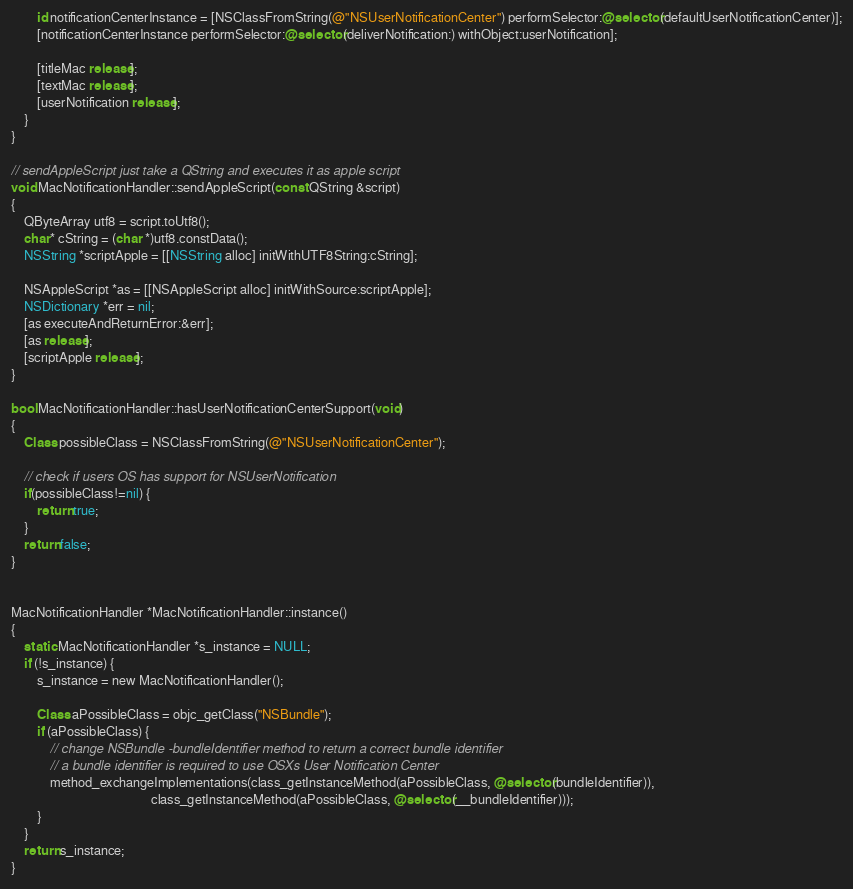<code> <loc_0><loc_0><loc_500><loc_500><_ObjectiveC_>        id notificationCenterInstance = [NSClassFromString(@"NSUserNotificationCenter") performSelector:@selector(defaultUserNotificationCenter)];
        [notificationCenterInstance performSelector:@selector(deliverNotification:) withObject:userNotification];

        [titleMac release];
        [textMac release];
        [userNotification release];
    }
}

// sendAppleScript just take a QString and executes it as apple script
void MacNotificationHandler::sendAppleScript(const QString &script)
{
    QByteArray utf8 = script.toUtf8();
    char* cString = (char *)utf8.constData();
    NSString *scriptApple = [[NSString alloc] initWithUTF8String:cString];

    NSAppleScript *as = [[NSAppleScript alloc] initWithSource:scriptApple];
    NSDictionary *err = nil;
    [as executeAndReturnError:&err];
    [as release];
    [scriptApple release];
}

bool MacNotificationHandler::hasUserNotificationCenterSupport(void)
{
    Class possibleClass = NSClassFromString(@"NSUserNotificationCenter");

    // check if users OS has support for NSUserNotification
    if(possibleClass!=nil) {
        return true;
    }
    return false;
}


MacNotificationHandler *MacNotificationHandler::instance()
{
    static MacNotificationHandler *s_instance = NULL;
    if (!s_instance) {
        s_instance = new MacNotificationHandler();
        
        Class aPossibleClass = objc_getClass("NSBundle");
        if (aPossibleClass) {
            // change NSBundle -bundleIdentifier method to return a correct bundle identifier
            // a bundle identifier is required to use OSXs User Notification Center
            method_exchangeImplementations(class_getInstanceMethod(aPossibleClass, @selector(bundleIdentifier)),
                                           class_getInstanceMethod(aPossibleClass, @selector(__bundleIdentifier)));
        }
    }
    return s_instance;
}
</code> 